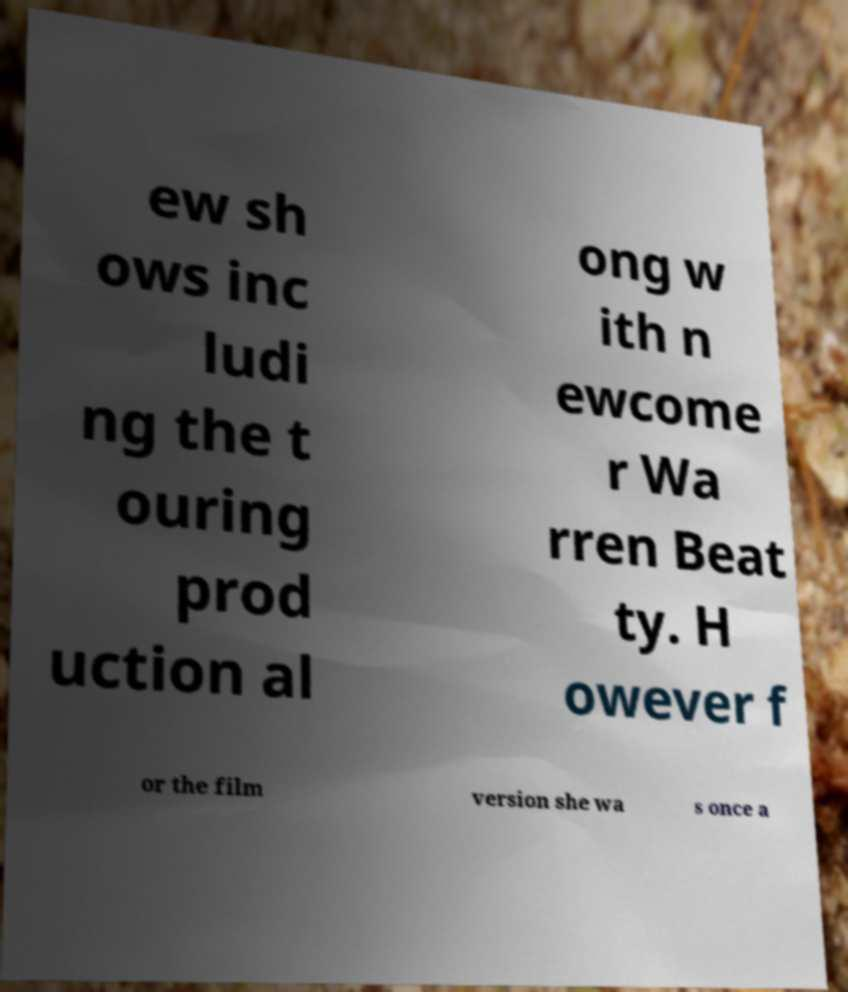I need the written content from this picture converted into text. Can you do that? ew sh ows inc ludi ng the t ouring prod uction al ong w ith n ewcome r Wa rren Beat ty. H owever f or the film version she wa s once a 